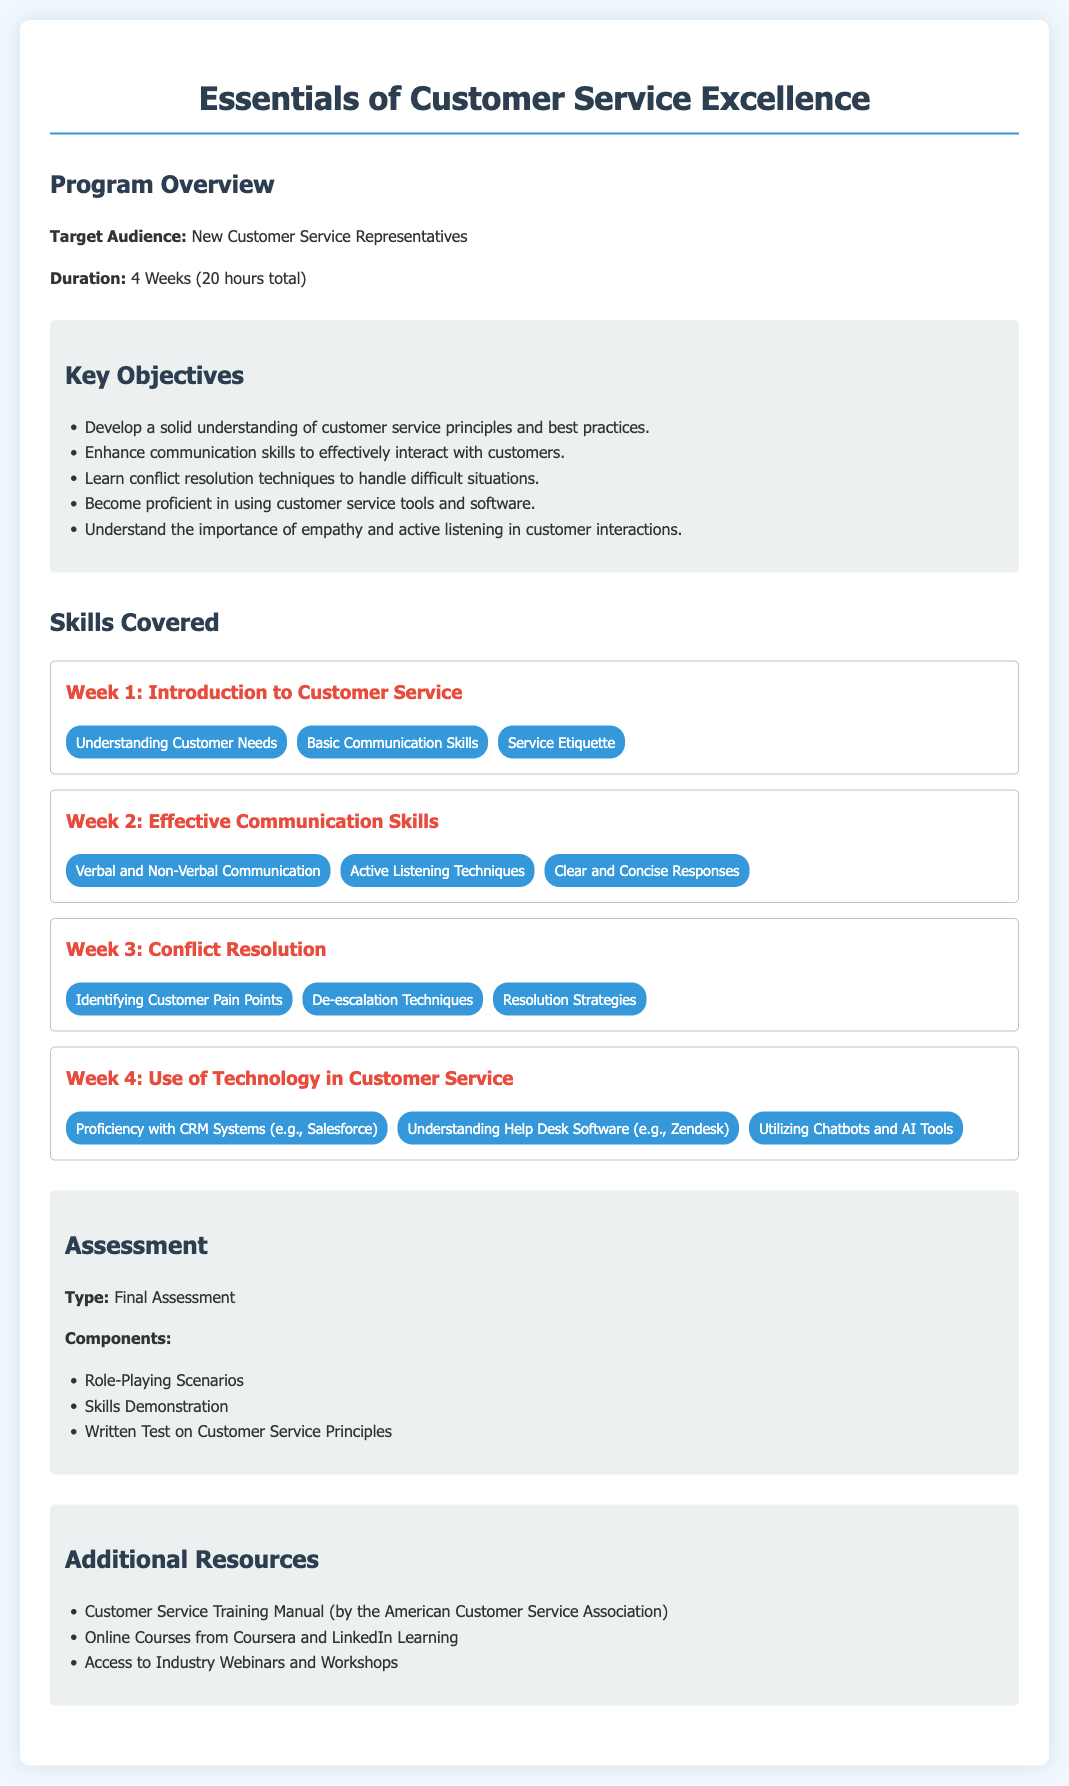What is the target audience for the training program? The document states that the target audience is new customer service representatives.
Answer: New Customer Service Representatives How long is the training program? The duration of the program is specified in the document as 4 weeks.
Answer: 4 Weeks What is one key objective of the training program? The document lists multiple objectives; one of them is enhancing communication skills.
Answer: Enhance communication skills Which week focuses on conflict resolution? The document outlines skills covered each week; conflict resolution is covered in Week 3.
Answer: Week 3 What types of assessments are included in the final assessment? The document mentions several assessment components, including role-playing scenarios.
Answer: Role-Playing Scenarios Which software is mentioned for proficiency in customer service tools? The document provides examples of software, including Salesforce.
Answer: Salesforce What is an example of a skill covered in Week 2? Week 2 covers effective communication skills, such as active listening techniques.
Answer: Active Listening Techniques How many total hours is the training program? The document specifies that the total duration of the program is 20 hours.
Answer: 20 hours 